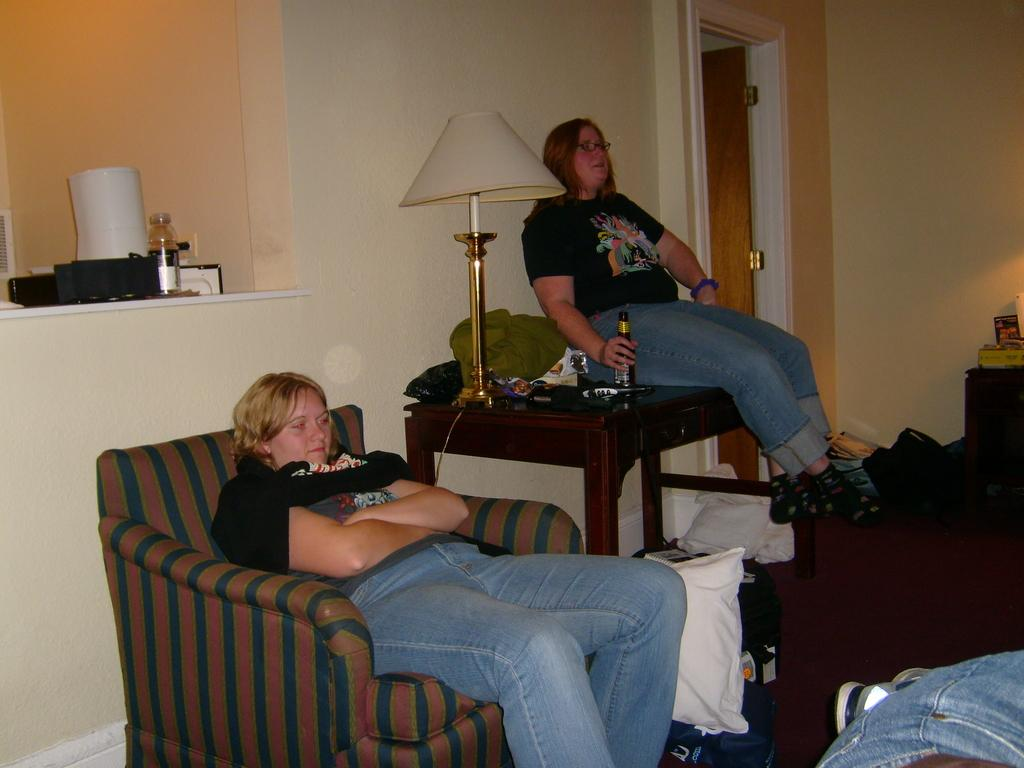What is the woman in the image holding? The woman is holding a bottle in the image. How is the woman holding the bottle positioned? The woman holding the bottle is sitting on a table. Who else is present in the image? There is another woman sitting beside her in a sofa. What type of balls are being discussed by the women in the image? There is no mention of balls in the image; the women are not discussing any balls. 